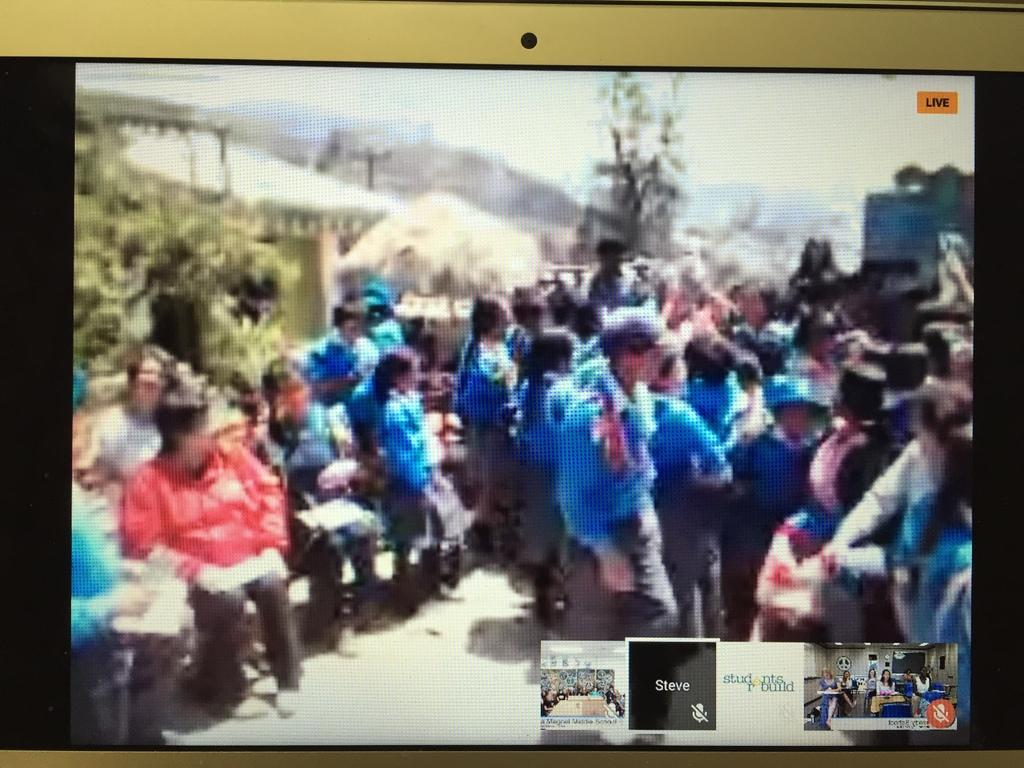What are the people in the image doing? There are people sitting on chairs and standing in the image. Where are the trees located in the image? The trees are on the left side of the image. What type of drum can be seen being played by a person in the image? There is no drum present in the image; the people are not playing any musical instruments. What color is the iron used by the person in the image? There is no iron present in the image, and therefore no ironing activity can be observed. 